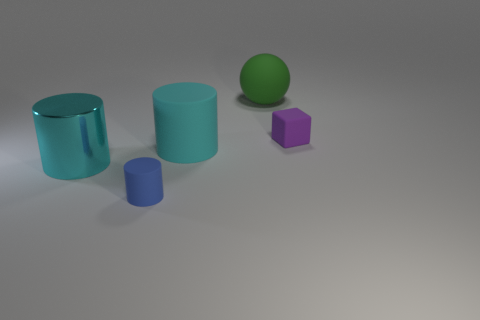Add 3 large purple matte cylinders. How many objects exist? 8 Subtract all spheres. How many objects are left? 4 Subtract all tiny brown cubes. Subtract all metal things. How many objects are left? 4 Add 2 large spheres. How many large spheres are left? 3 Add 3 small brown cubes. How many small brown cubes exist? 3 Subtract 0 yellow balls. How many objects are left? 5 